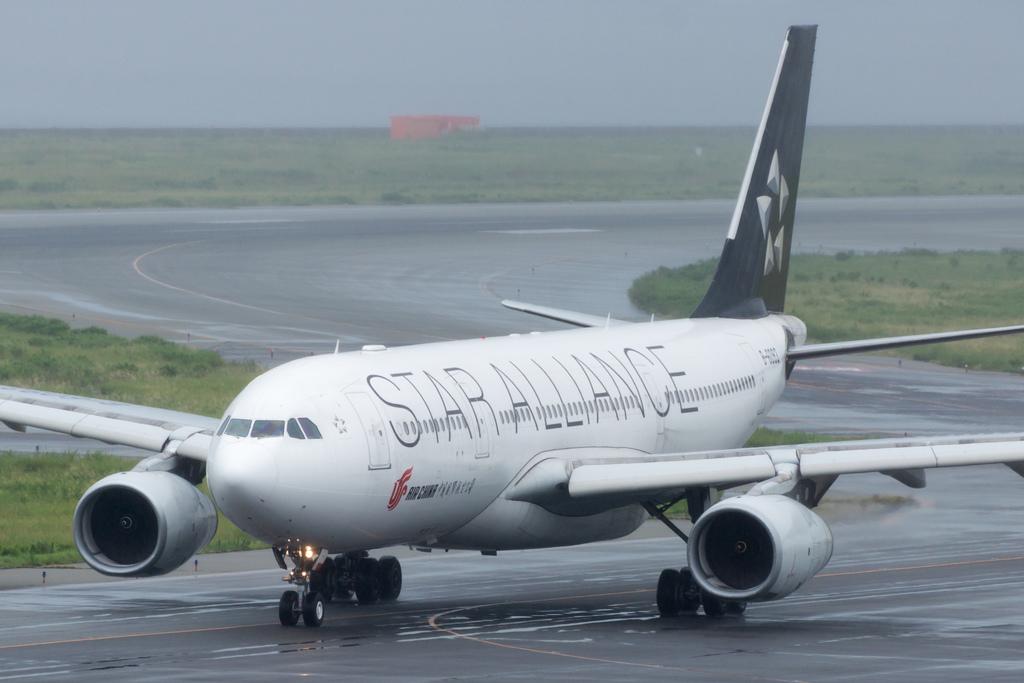Is that plane part of the star alliance?
Your answer should be compact. Yes. 